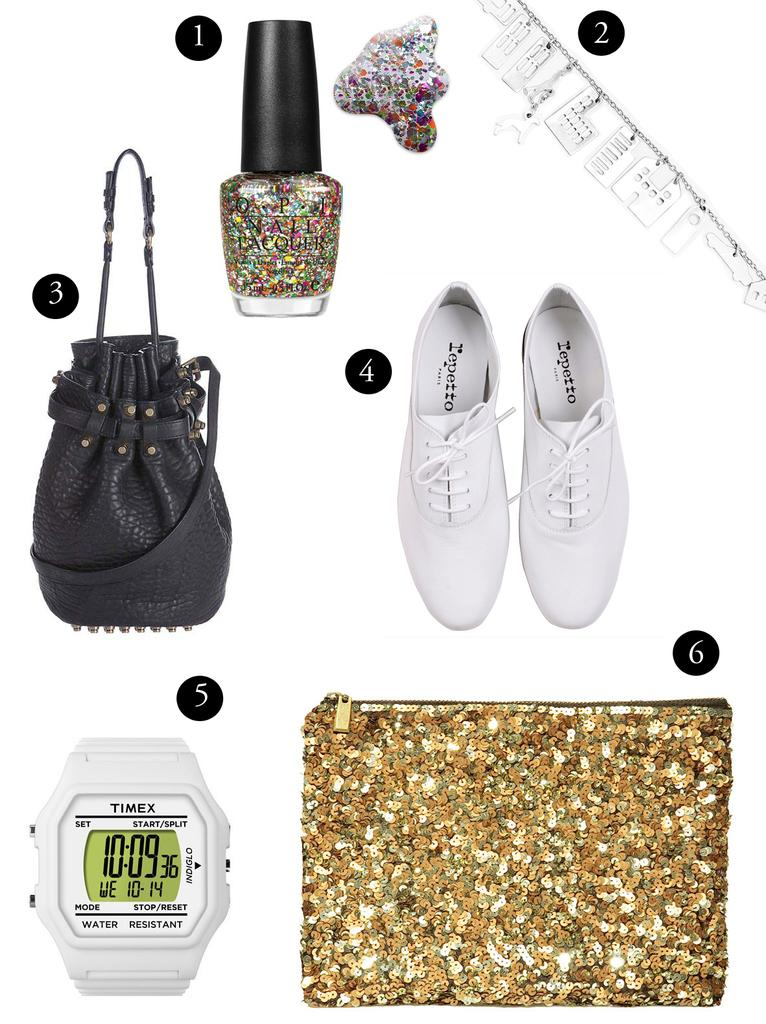Provide a one-sentence caption for the provided image. A numbered selection of accessories and apparel are on a white background. 